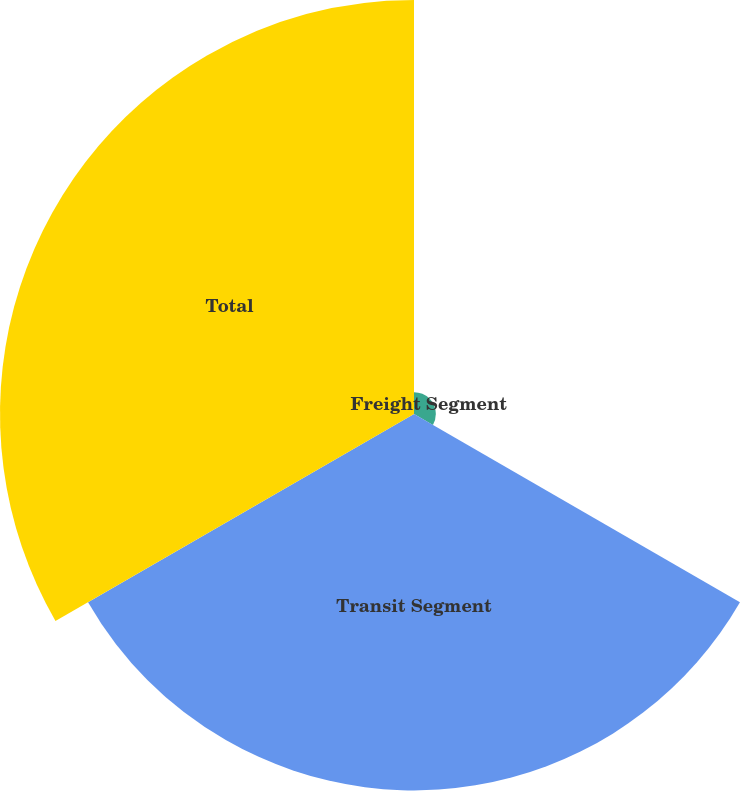Convert chart. <chart><loc_0><loc_0><loc_500><loc_500><pie_chart><fcel>Freight Segment<fcel>Transit Segment<fcel>Total<nl><fcel>2.69%<fcel>46.34%<fcel>50.97%<nl></chart> 